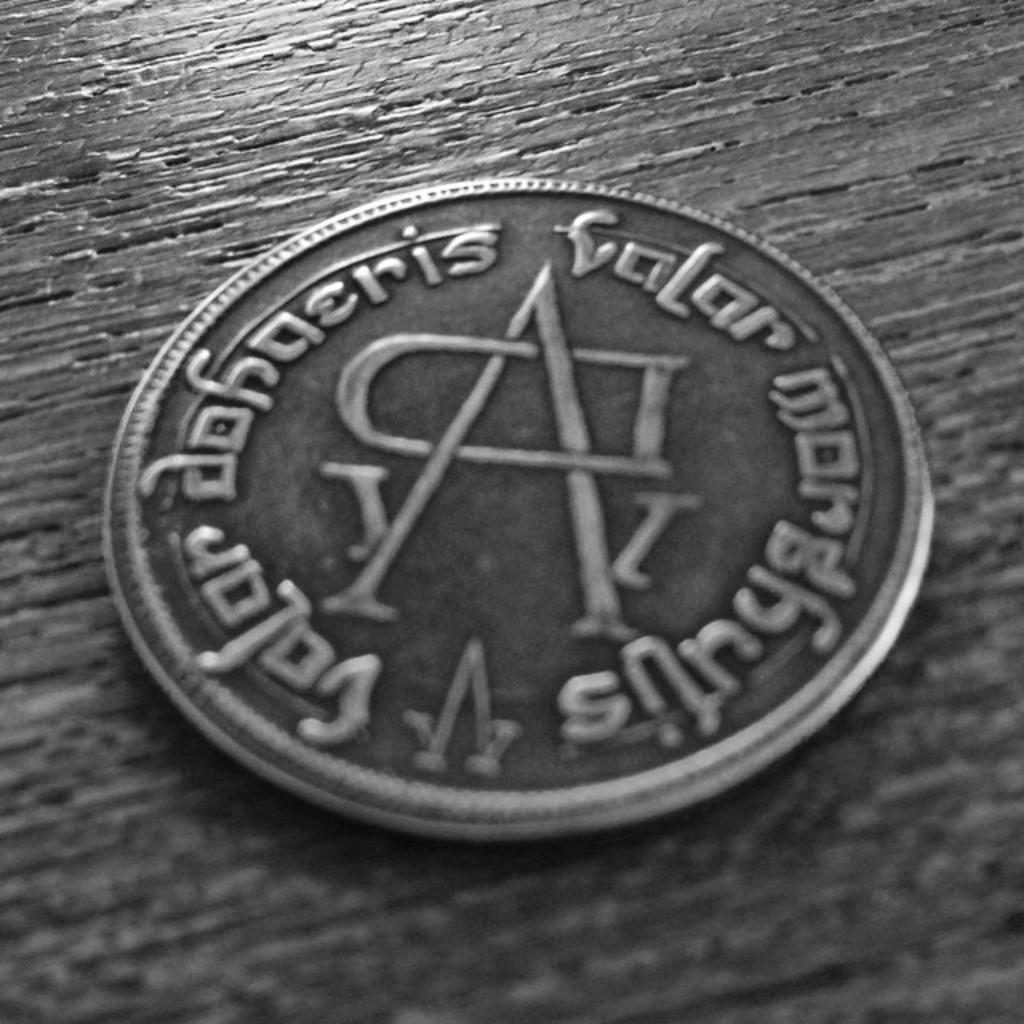<image>
Give a short and clear explanation of the subsequent image. Valar Dohaeris Valar Morghuus is etched around the side of this coin. 